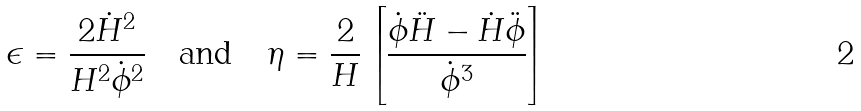<formula> <loc_0><loc_0><loc_500><loc_500>\epsilon = \frac { 2 \dot { H } ^ { 2 } } { H ^ { 2 } \dot { \phi } ^ { 2 } } \quad \text {and} \quad \eta = \frac { 2 } { H } \left [ \frac { \dot { \phi } \ddot { H } - \dot { H } \ddot { \phi } } { \dot { \phi } ^ { 3 } } \right ]</formula> 